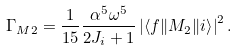<formula> <loc_0><loc_0><loc_500><loc_500>\Gamma _ { M 2 } = \frac { 1 } { 1 5 } \frac { \alpha ^ { 5 } \omega ^ { 5 } } { 2 J _ { i } + 1 } \left | \left < f \| M _ { 2 } \| i \right > \right | ^ { 2 } .</formula> 